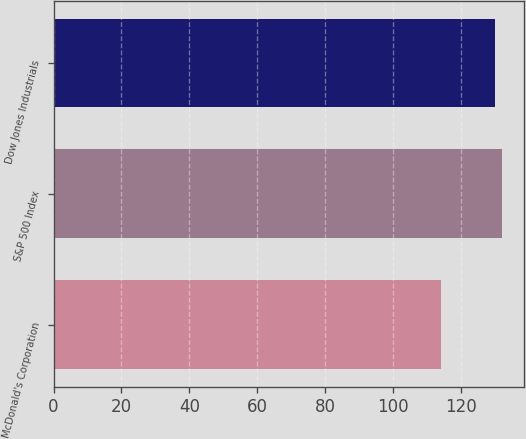Convert chart to OTSL. <chart><loc_0><loc_0><loc_500><loc_500><bar_chart><fcel>McDonald's Corporation<fcel>S&P 500 Index<fcel>Dow Jones Industrials<nl><fcel>114<fcel>132<fcel>130<nl></chart> 